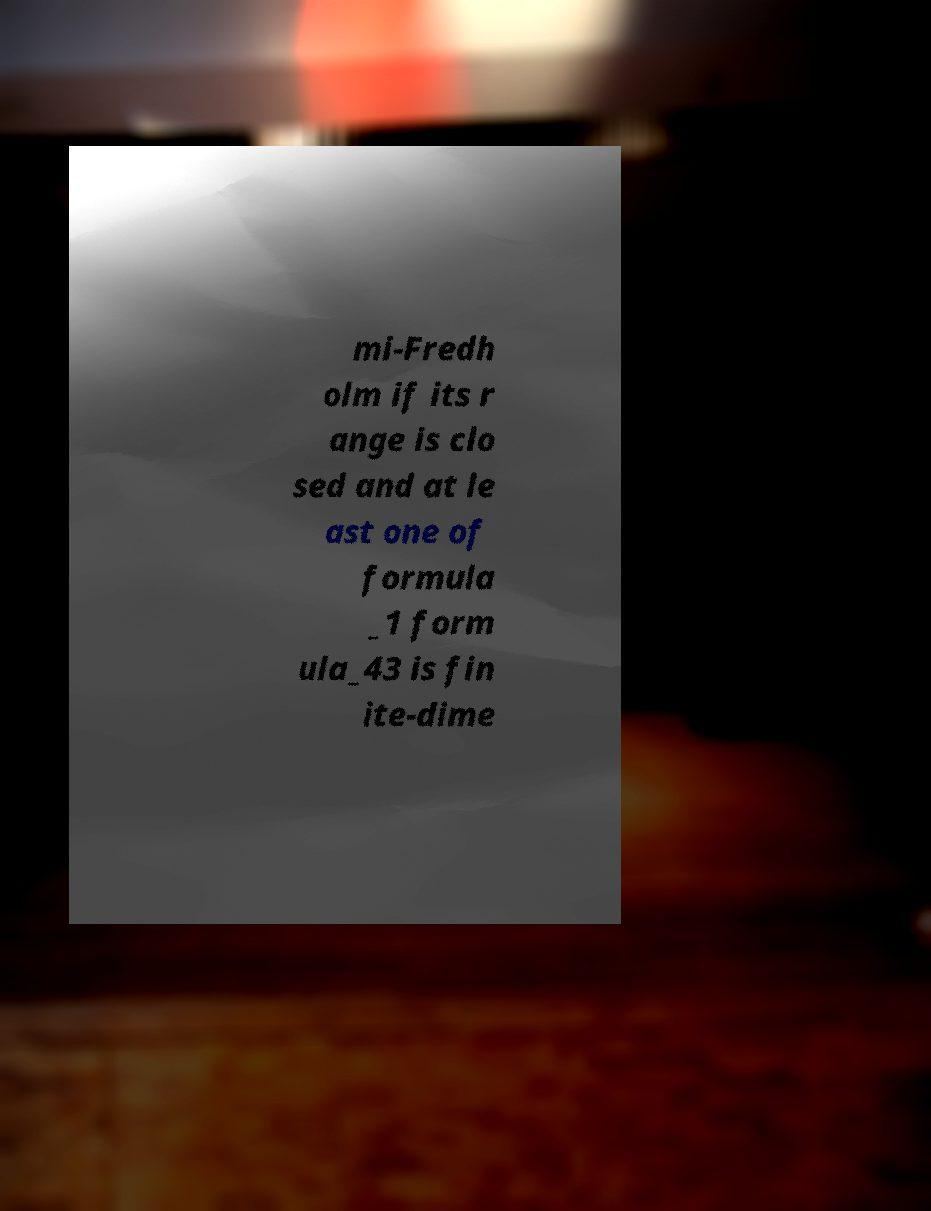Please identify and transcribe the text found in this image. mi-Fredh olm if its r ange is clo sed and at le ast one of formula _1 form ula_43 is fin ite-dime 